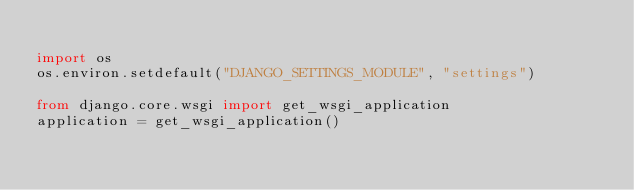<code> <loc_0><loc_0><loc_500><loc_500><_Python_>
import os
os.environ.setdefault("DJANGO_SETTINGS_MODULE", "settings")

from django.core.wsgi import get_wsgi_application
application = get_wsgi_application()
</code> 